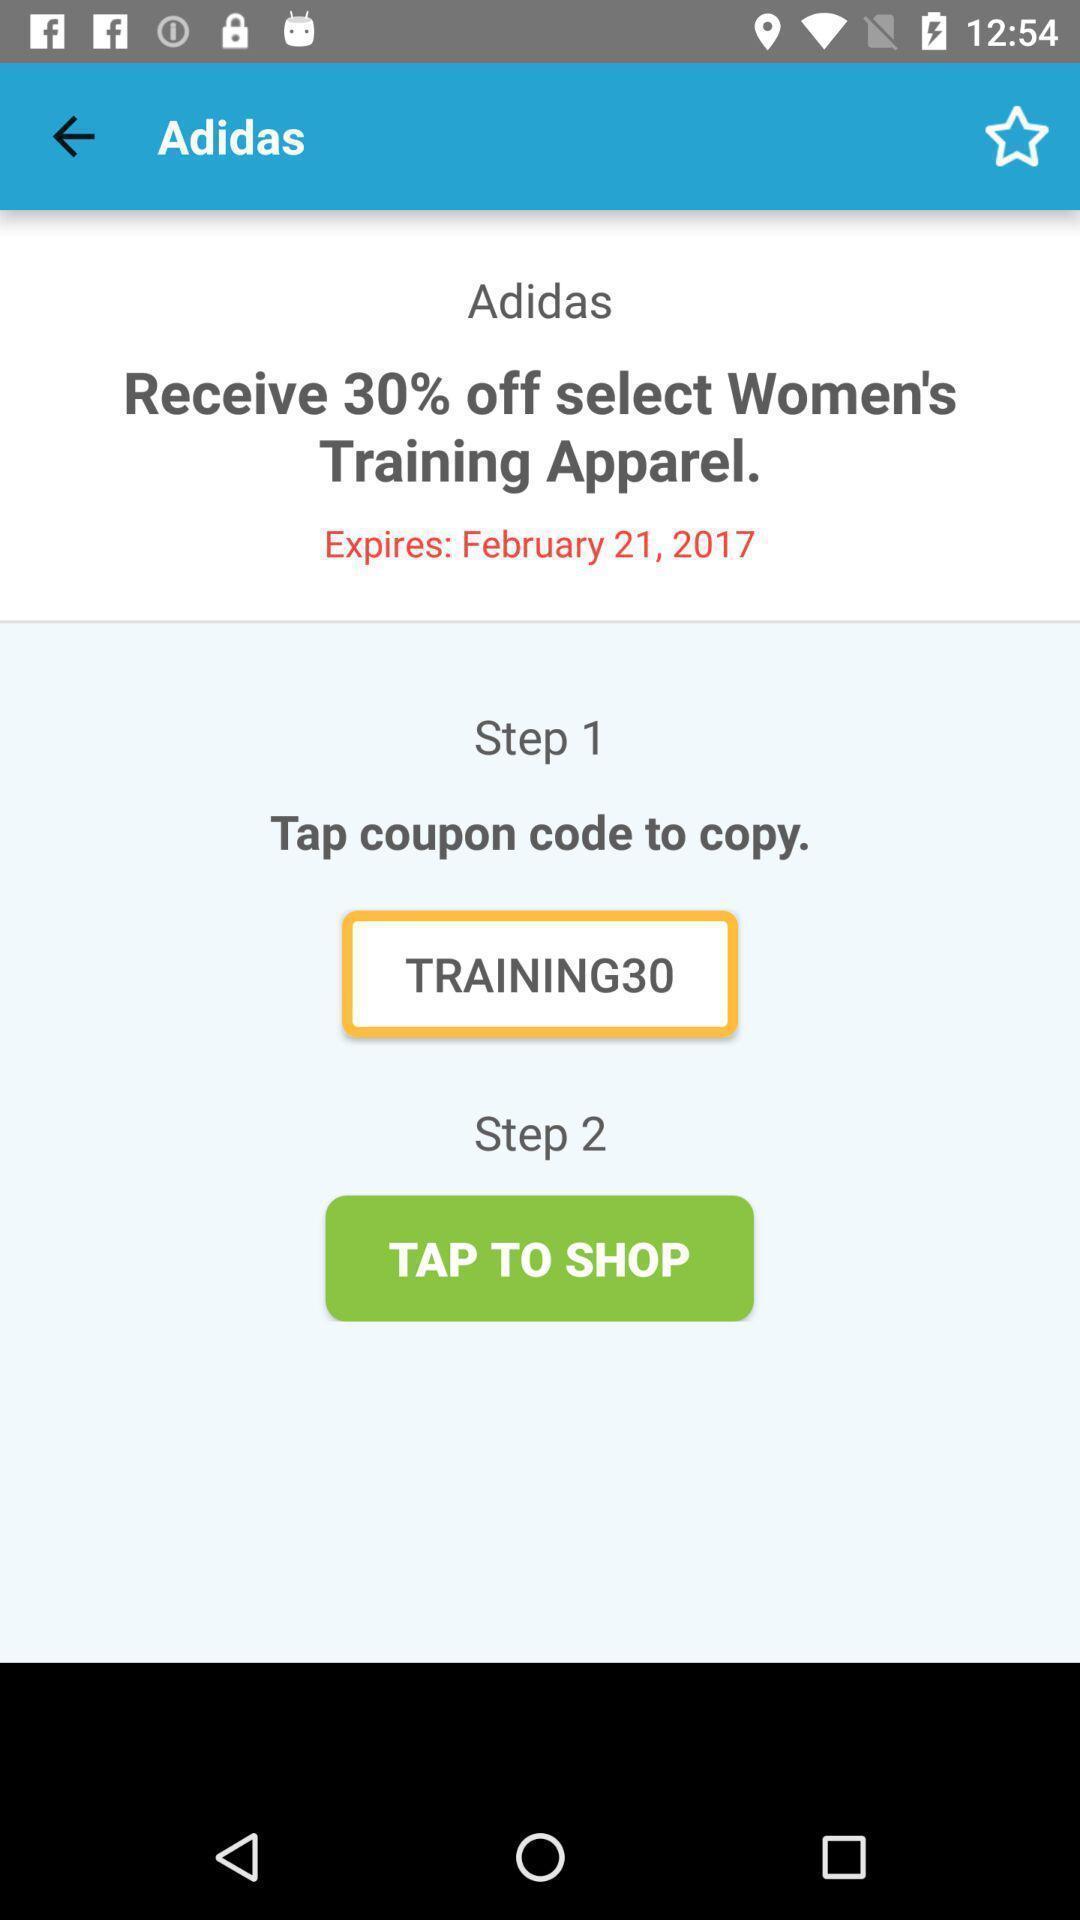Tell me what you see in this picture. Screen showing step 1 and step 2. 